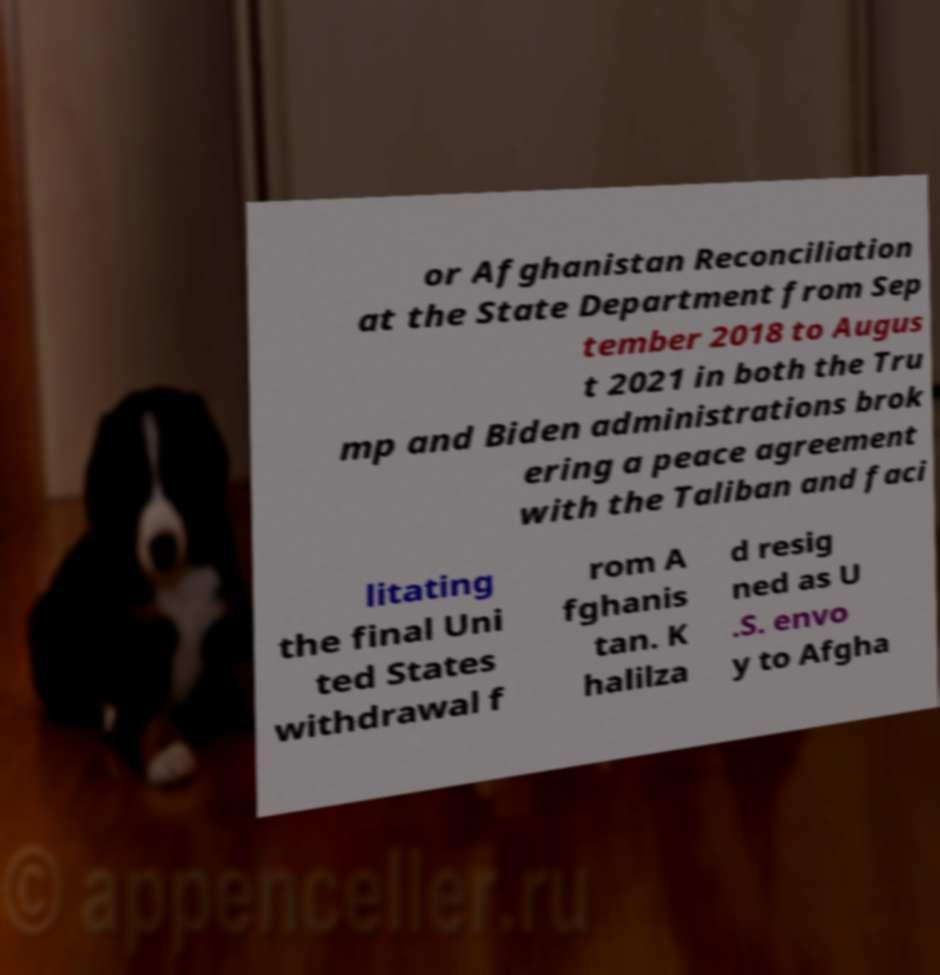For documentation purposes, I need the text within this image transcribed. Could you provide that? or Afghanistan Reconciliation at the State Department from Sep tember 2018 to Augus t 2021 in both the Tru mp and Biden administrations brok ering a peace agreement with the Taliban and faci litating the final Uni ted States withdrawal f rom A fghanis tan. K halilza d resig ned as U .S. envo y to Afgha 